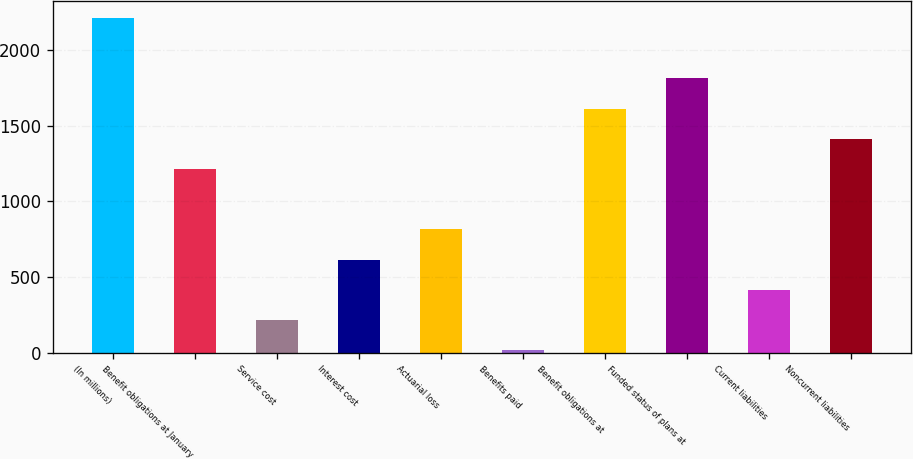Convert chart to OTSL. <chart><loc_0><loc_0><loc_500><loc_500><bar_chart><fcel>(In millions)<fcel>Benefit obligations at January<fcel>Service cost<fcel>Interest cost<fcel>Actuarial loss<fcel>Benefits paid<fcel>Benefit obligations at<fcel>Funded status of plans at<fcel>Current liabilities<fcel>Noncurrent liabilities<nl><fcel>2211.5<fcel>1214<fcel>216.5<fcel>615.5<fcel>815<fcel>17<fcel>1613<fcel>1812.5<fcel>416<fcel>1413.5<nl></chart> 